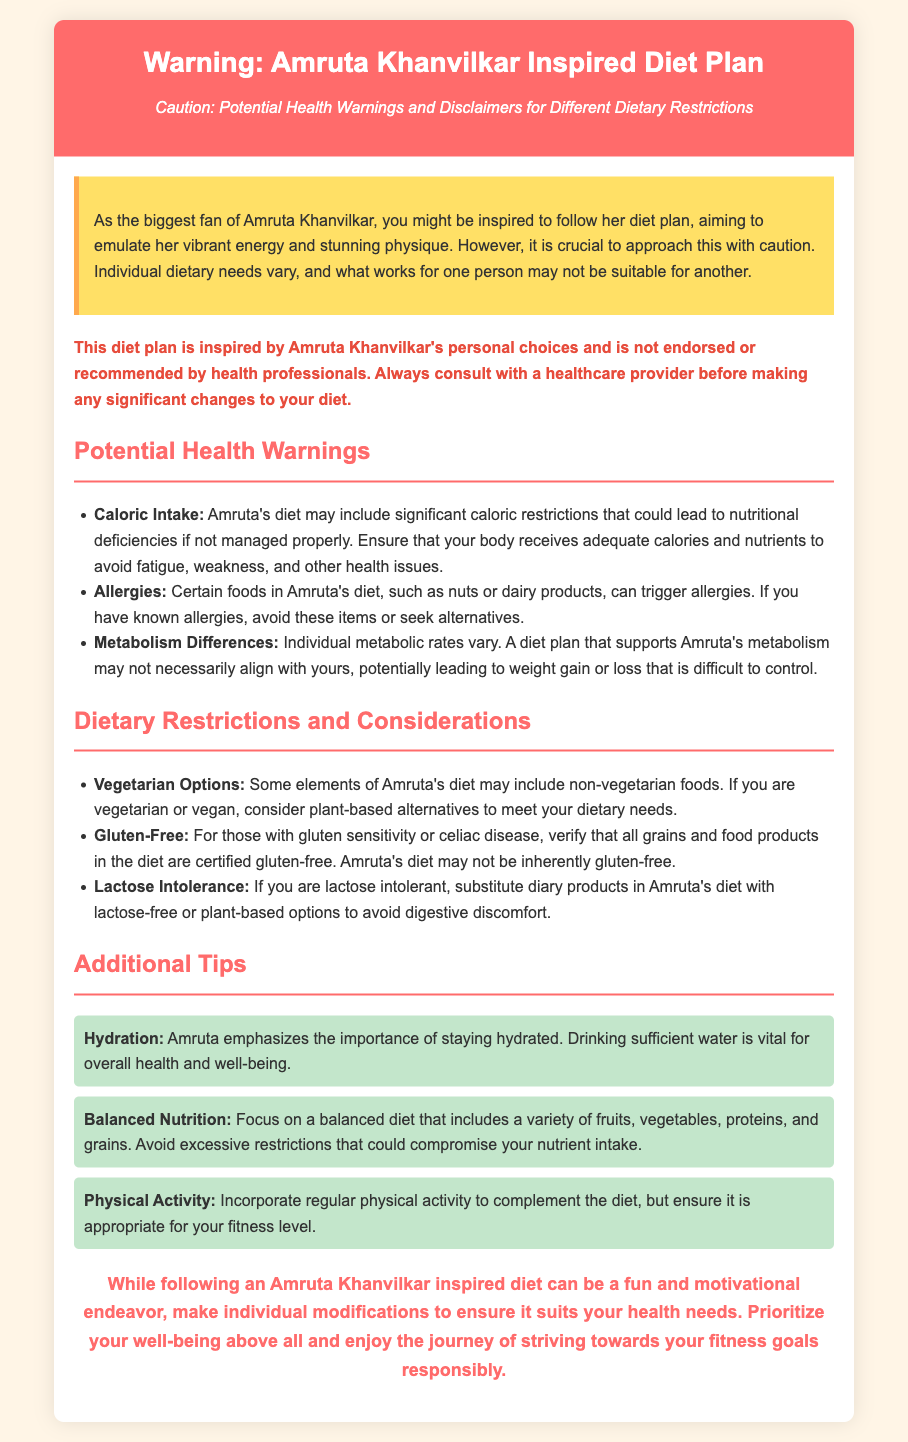What is the title of the document? The title of the document is found in the header section, which clearly states the subject matter.
Answer: Warning: Amruta Khanvilkar Inspired Diet Plan Who is the diet plan inspired by? The document mentions the individual whose diet plan serves as an inspiration.
Answer: Amruta Khanvilkar What color is used for the warning box? The document specifies the background color of the warning box for emphasis.
Answer: Yellow Which dietary restriction is mentioned for those with allergies? The document discusses a specific dietary concern for individuals with certain allergies.
Answer: Nuts or dairy products What is a key emphasis mentioned in the additional tips section? The document lists an important health aspect as per Amruta's emphasis.
Answer: Hydration What should individuals do before making significant dietary changes? The document advises a specific action that individuals should take regarding their health.
Answer: Consult with a healthcare provider What kind of options does Amruta's diet include for vegetarians? The document refers to dietary preferences and alternatives concerning vegetarianism.
Answer: Non-vegetarian foods What could caloric restrictions in Amruta's diet lead to? The document mentions a potential consequence of caloric restrictions in the diet.
Answer: Nutritional deficiencies 